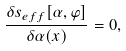Convert formula to latex. <formula><loc_0><loc_0><loc_500><loc_500>\frac { \delta s _ { e f f } [ \alpha , \varphi ] } { \delta \alpha ( x ) } = 0 ,</formula> 